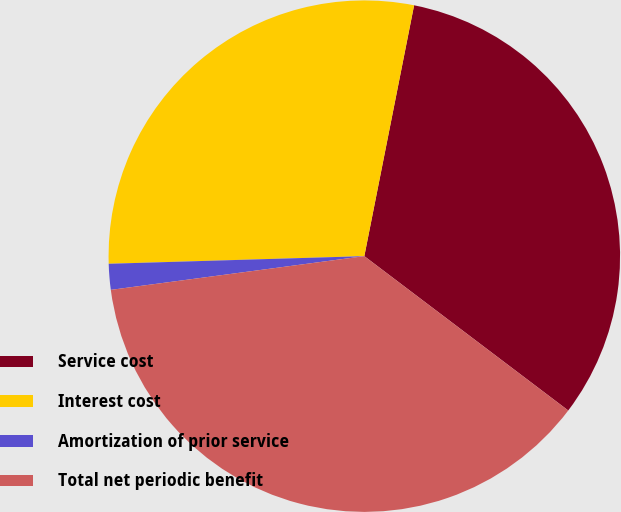<chart> <loc_0><loc_0><loc_500><loc_500><pie_chart><fcel>Service cost<fcel>Interest cost<fcel>Amortization of prior service<fcel>Total net periodic benefit<nl><fcel>32.19%<fcel>28.59%<fcel>1.63%<fcel>37.58%<nl></chart> 